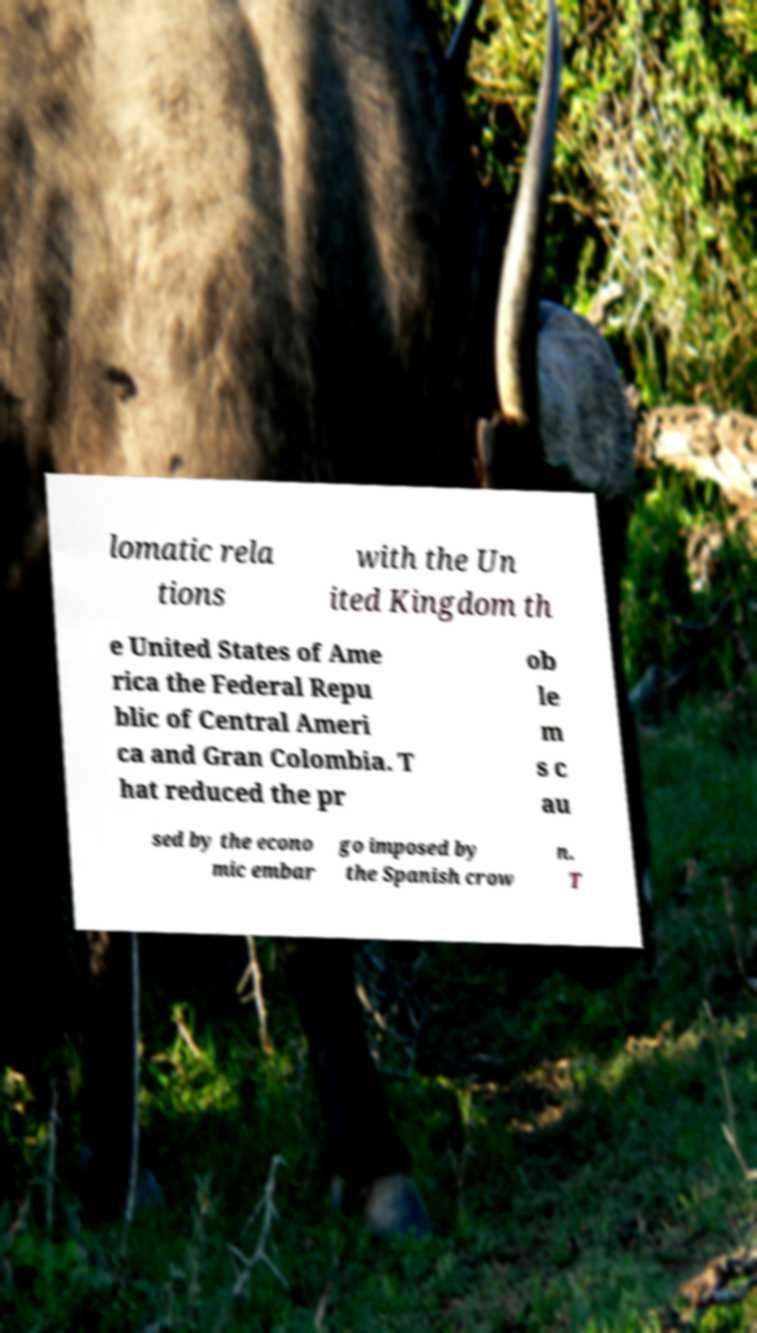Please identify and transcribe the text found in this image. lomatic rela tions with the Un ited Kingdom th e United States of Ame rica the Federal Repu blic of Central Ameri ca and Gran Colombia. T hat reduced the pr ob le m s c au sed by the econo mic embar go imposed by the Spanish crow n. T 